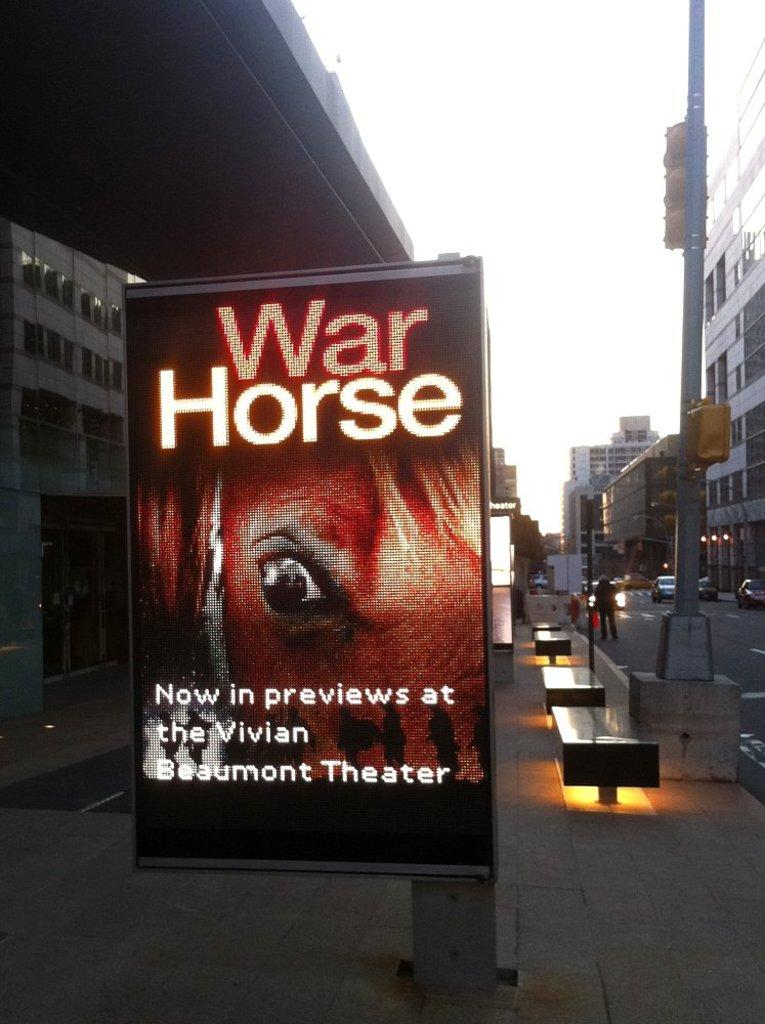<image>
Write a terse but informative summary of the picture. The War house is a brand new interesting show. 